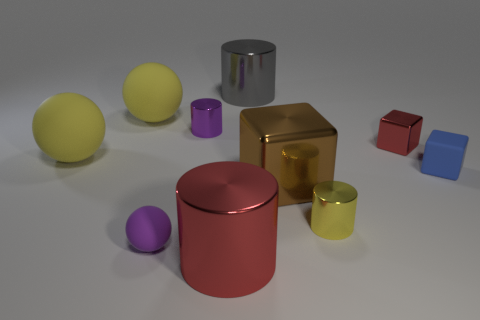Subtract all blocks. How many objects are left? 7 Subtract all brown cubes. Subtract all cylinders. How many objects are left? 5 Add 1 big metal blocks. How many big metal blocks are left? 2 Add 7 yellow things. How many yellow things exist? 10 Subtract 0 brown balls. How many objects are left? 10 